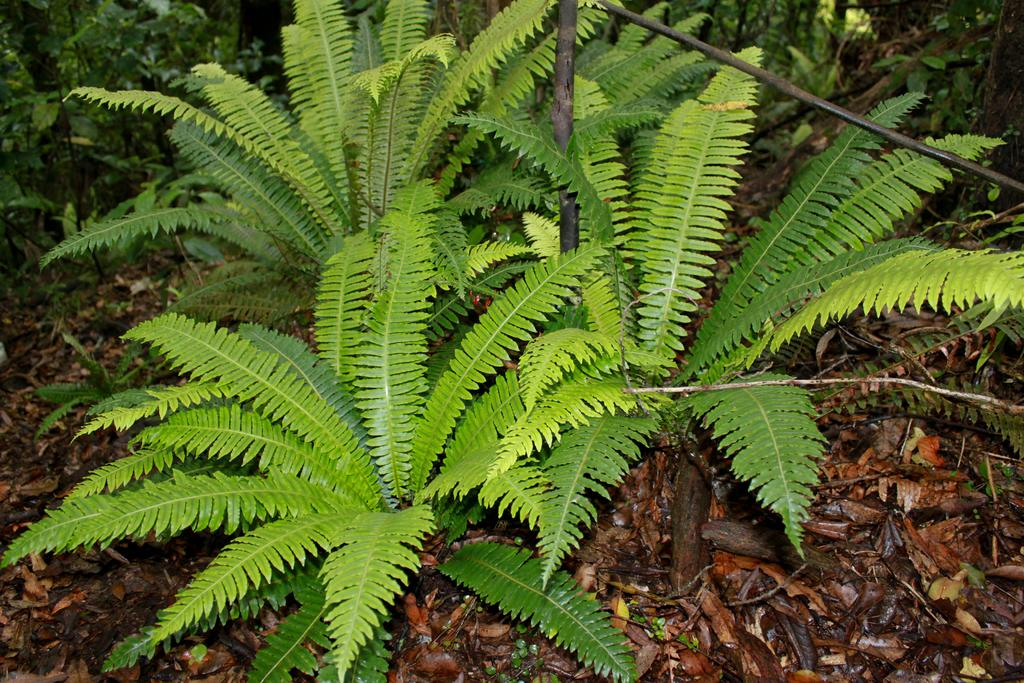What type of living organisms can be seen in the image? Plants can be seen in the image. Can you describe any man-made objects in the background of the image? There are two pipes in the background of the image. How many mice can be seen running on the tracks in the image? There are no mice or tracks present in the image. 